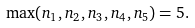<formula> <loc_0><loc_0><loc_500><loc_500>\max ( n _ { 1 } , n _ { 2 } , n _ { 3 } , n _ { 4 } , n _ { 5 } ) = 5 .</formula> 